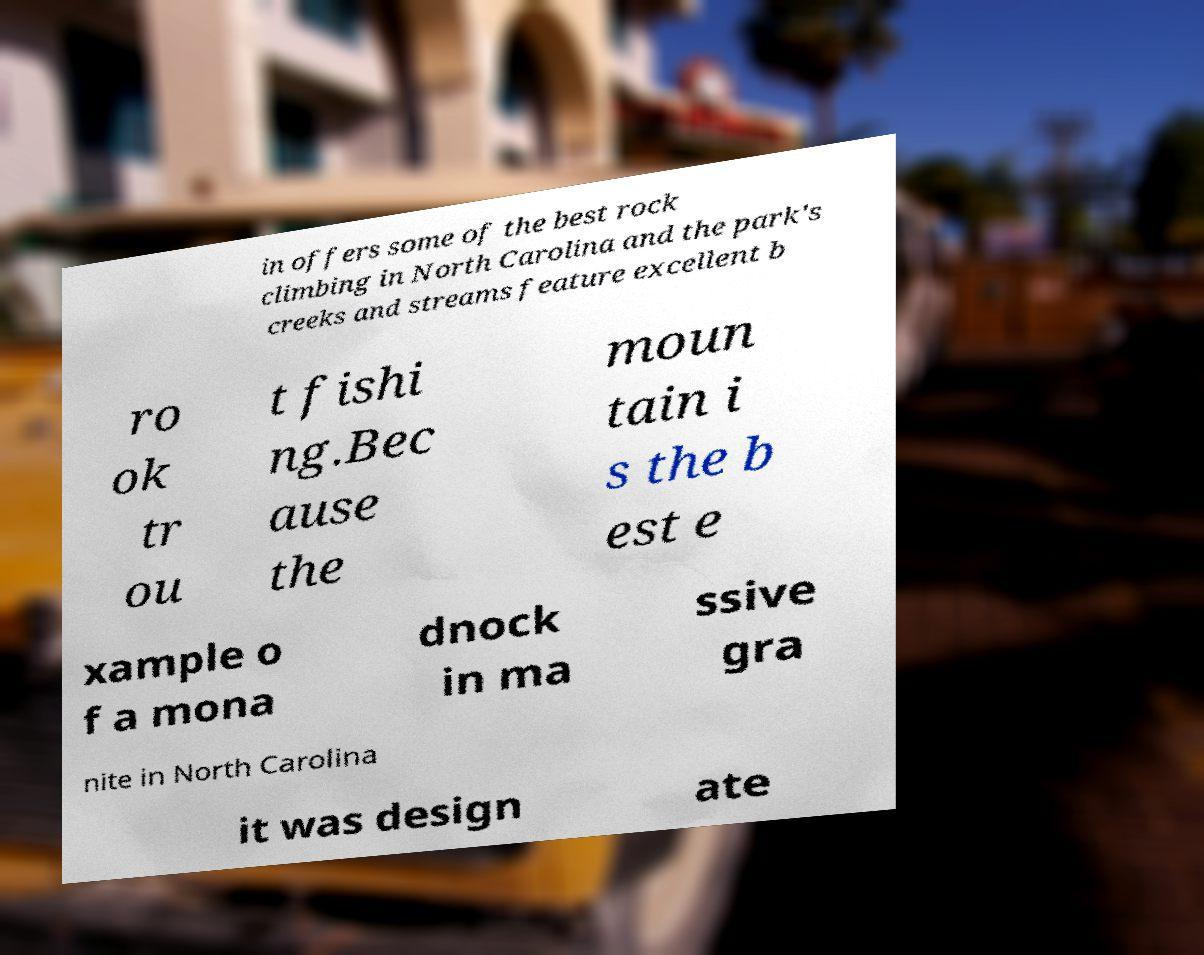What messages or text are displayed in this image? I need them in a readable, typed format. in offers some of the best rock climbing in North Carolina and the park's creeks and streams feature excellent b ro ok tr ou t fishi ng.Bec ause the moun tain i s the b est e xample o f a mona dnock in ma ssive gra nite in North Carolina it was design ate 